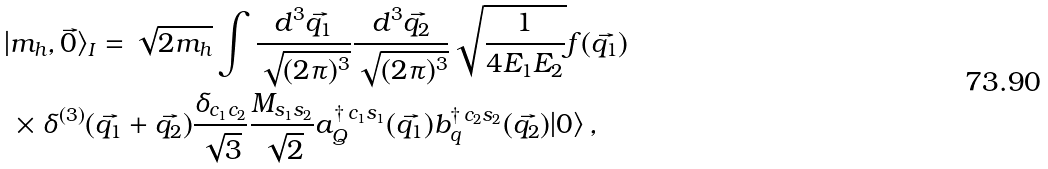<formula> <loc_0><loc_0><loc_500><loc_500>| & m _ { h } , { \vec { 0 } } \rangle _ { I } = \sqrt { 2 m _ { h } } \int \frac { d ^ { 3 } \vec { q _ { 1 } } } { \sqrt { ( 2 \pi ) ^ { 3 } } } \frac { d ^ { 3 } \vec { q _ { 2 } } } { \sqrt { ( 2 \pi ) ^ { 3 } } } \sqrt { \frac { 1 } { 4 E _ { 1 } E _ { 2 } } } f ( { \vec { q _ { 1 } } } ) \\ & \times \delta ^ { ( 3 ) } ( { \vec { q _ { 1 } } } + { \vec { q _ { 2 } } } ) \frac { \delta _ { c _ { 1 } c _ { 2 } } } { \sqrt { 3 } } \frac { M _ { s _ { 1 } s _ { 2 } } } { \sqrt { 2 } } { a } _ { Q } ^ { \dagger \, c _ { 1 } s _ { 1 } } ( { \vec { q _ { 1 } } } ) { b } _ { q } ^ { \dagger \, c _ { 2 } s _ { 2 } } ( { \vec { q _ { 2 } } } ) | 0 \rangle \, ,</formula> 